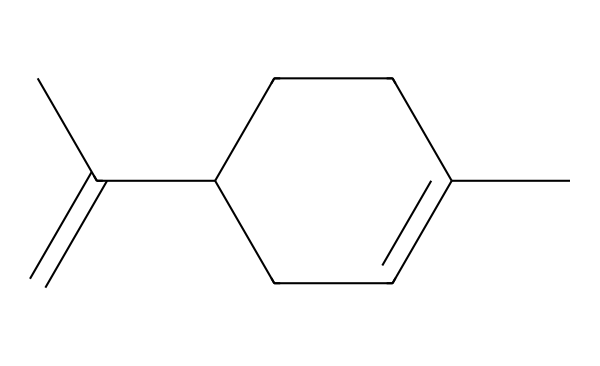What is the molecular formula of limonene? To determine the molecular formula, count the carbon (C) and hydrogen (H) atoms from the SMILES. The structure has 10 carbon atoms and 16 hydrogen atoms, resulting in the formula C10H16.
Answer: C10H16 How many rings are present in this structure? The SMILES representation shows one part indicating a ring (CC1=CCC). This means there is one cyclic structure in the molecule.
Answer: 1 What type of hydrocarbon is limonene classified as? Limonene has a structure with both single and double bonds but no functional groups, making it an unsaturated hydrocarbon, specifically a mono-terpene.
Answer: monoterpene What is the degree of unsaturation in limonene? The degree of unsaturation can be calculated using the formula (2C + 2 + N - H - X)/2. Here C = 10, H = 16, leading to (2*10 + 2 - 16)/2 = 3, indicating three degrees of unsaturation due to the presence of double bonds and the ring structure.
Answer: 3 How many double bonds are present in limonene? Analyzing the chemical structure, there is one double bond between two carbon atoms that is visually indicated in the 'C=C' part of the SMILES representation.
Answer: 1 What functional group is associated with the characteristic fragrance of limonene? While limonene itself does not contain traditional functional groups like alcohols or amines, its unique structure, especially the double bond and various carbon arrangements create its characteristic citrus scent. This scent is inferred from terpene classification rather than a specific functional group.
Answer: terpene What is the primary source of limonene in nature? Limonene is primarily obtained from citrus fruit peels, such as oranges and lemons, which are rich in this fragrant compound.
Answer: citrus peels 